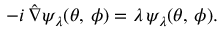<formula> <loc_0><loc_0><loc_500><loc_500>- i \, \hat { \nabla } \psi _ { \lambda } ( \theta , \, \phi ) = \lambda \, \psi _ { \lambda } ( \theta , \, \phi ) .</formula> 